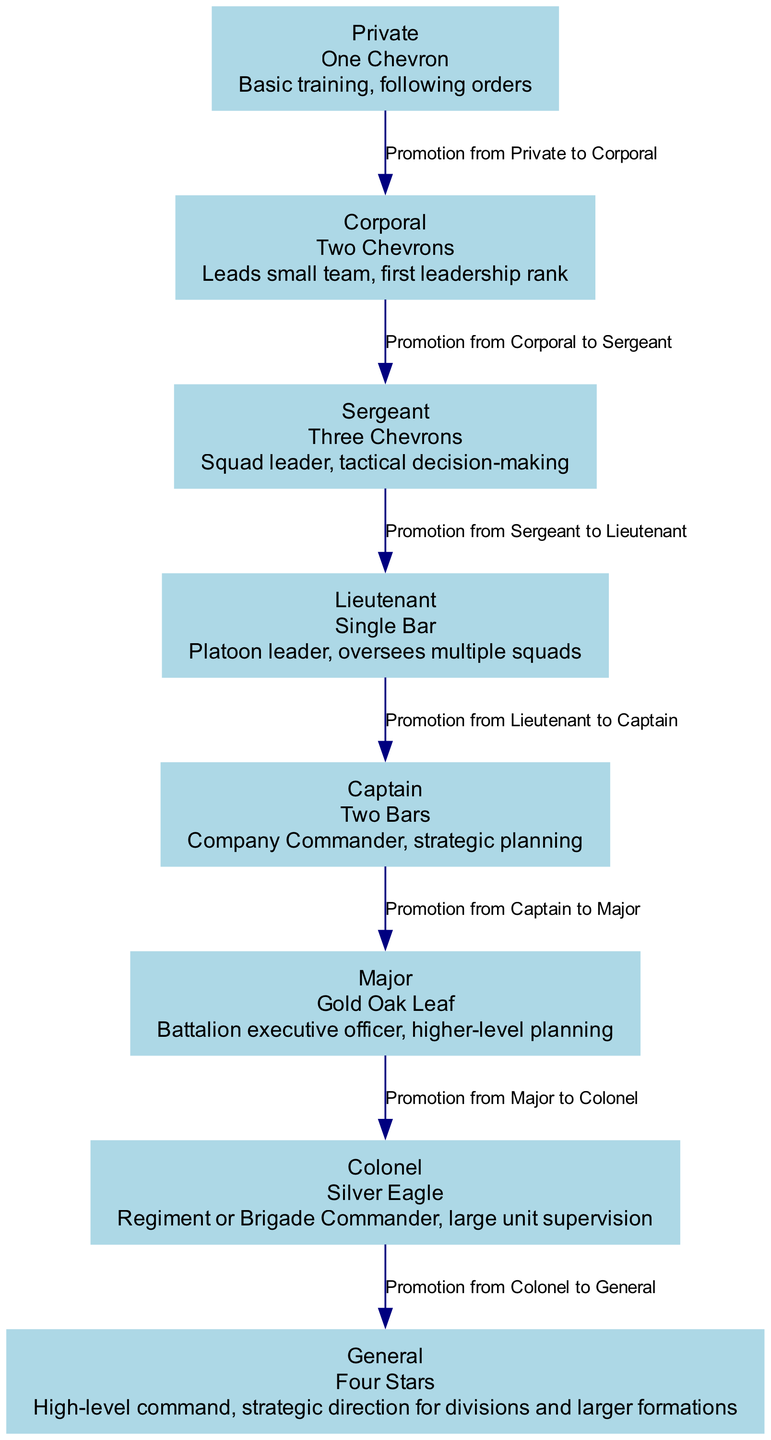What is the highest military rank in the diagram? The diagram shows a hierarchy of military ranks with "General" listed at the top, indicating it is the highest rank in the structure.
Answer: General What insignia does a Lieutenant have? Looking at the node for "Lieutenant," it states that the insignia is a "Single Bar," which is the symbol used for this rank.
Answer: Single Bar How many ranks are displayed in the diagram? The data describes a total of 8 military ranks listed from the lowest to the highest, meaning there are 8 nodes in total.
Answer: 8 What is the responsibility of a Corporal? According to the "Corporal" node, the responsibility is to "Leads small team, first leadership rank," which details what they are expected to do.
Answer: Leads small team, first leadership rank What rank comes after Sergeant in the promotion structure? The diagram edges indicate that the rank directly after "Sergeant" is "Lieutenant," as shown by the arrow connecting the two nodes.
Answer: Lieutenant Which rank has two Chevrons as its insignia? Referring to the "Corporal" node, it mentions that the insignia for this rank is "Two Chevrons," clearly identifying the insignia associated with Corporal.
Answer: Two Chevrons What is the role of a Major? The node for "Major" specifies the role as "Battalion executive officer, higher-level planning," indicating its responsibility within the military hierarchy.
Answer: Battalion executive officer, higher-level planning How does one get promoted from Captain to Major? The diagram shows an edge between "Captain" and "Major" labeled "Promotion from Captain to Major," indicating the relationship between these two ranks in terms of promotion.
Answer: Promotion from Captain to Major What is the primary responsibility of a General? In the "General" node, it outlines the responsibility as "High-level command, strategic direction for divisions and larger formations," summarizing the duties at this rank.
Answer: High-level command, strategic direction for divisions and larger formations 